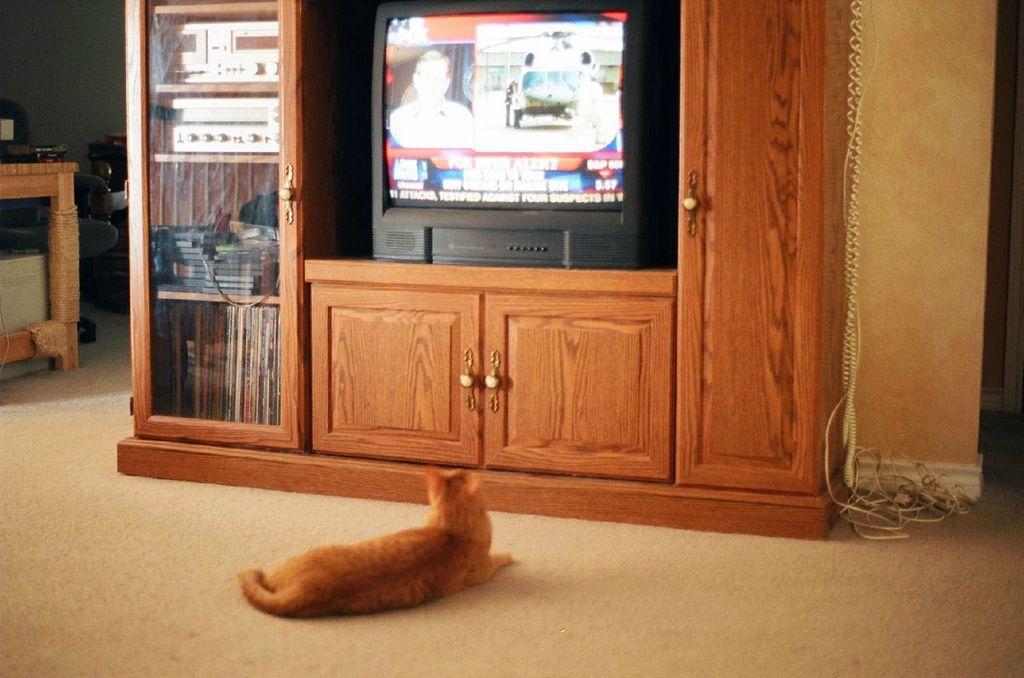Can you describe this image briefly? In this image we can see a cat sitting in front of a cupboard which consist of books, television and a few other objects, on the top left corner of the image there is a chair, a table, books and some other objects. 